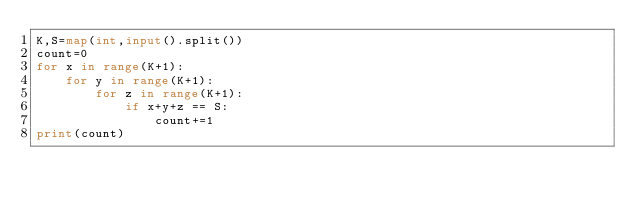<code> <loc_0><loc_0><loc_500><loc_500><_Python_>K,S=map(int,input().split())
count=0
for x in range(K+1):
    for y in range(K+1):
        for z in range(K+1):
            if x+y+z == S:
                count+=1
print(count)</code> 